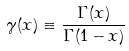<formula> <loc_0><loc_0><loc_500><loc_500>\gamma ( x ) \equiv \frac { \Gamma ( x ) } { \Gamma ( 1 - x ) }</formula> 